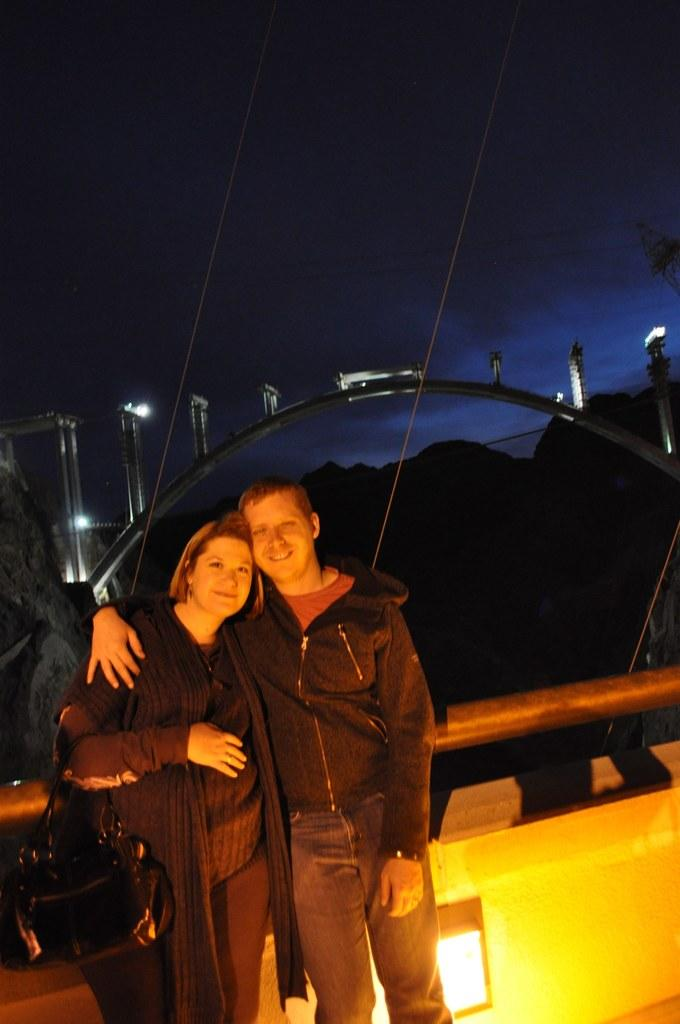How many people are in the image? There are two people in the image, a man and a woman. What are the man and woman doing in the image? The man and woman are posing for a camera. What expressions do the man and woman have in the image? The man and woman are both smiling in the image. What is the woman holding in the image? The woman is holding a bag with her hand. What can be seen in the image that provides illumination? There are lights in the image. What architectural feature is present in the image? There is an arch in the image. How would you describe the background of the image? The background of the image is dark. What type of rake is being used to design the chin of the man in the image? There is no rake or chin design present in the image; it features a man and a woman posing for a camera. 